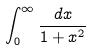<formula> <loc_0><loc_0><loc_500><loc_500>\int _ { 0 } ^ { \infty } \frac { d x } { 1 + x ^ { 2 } }</formula> 